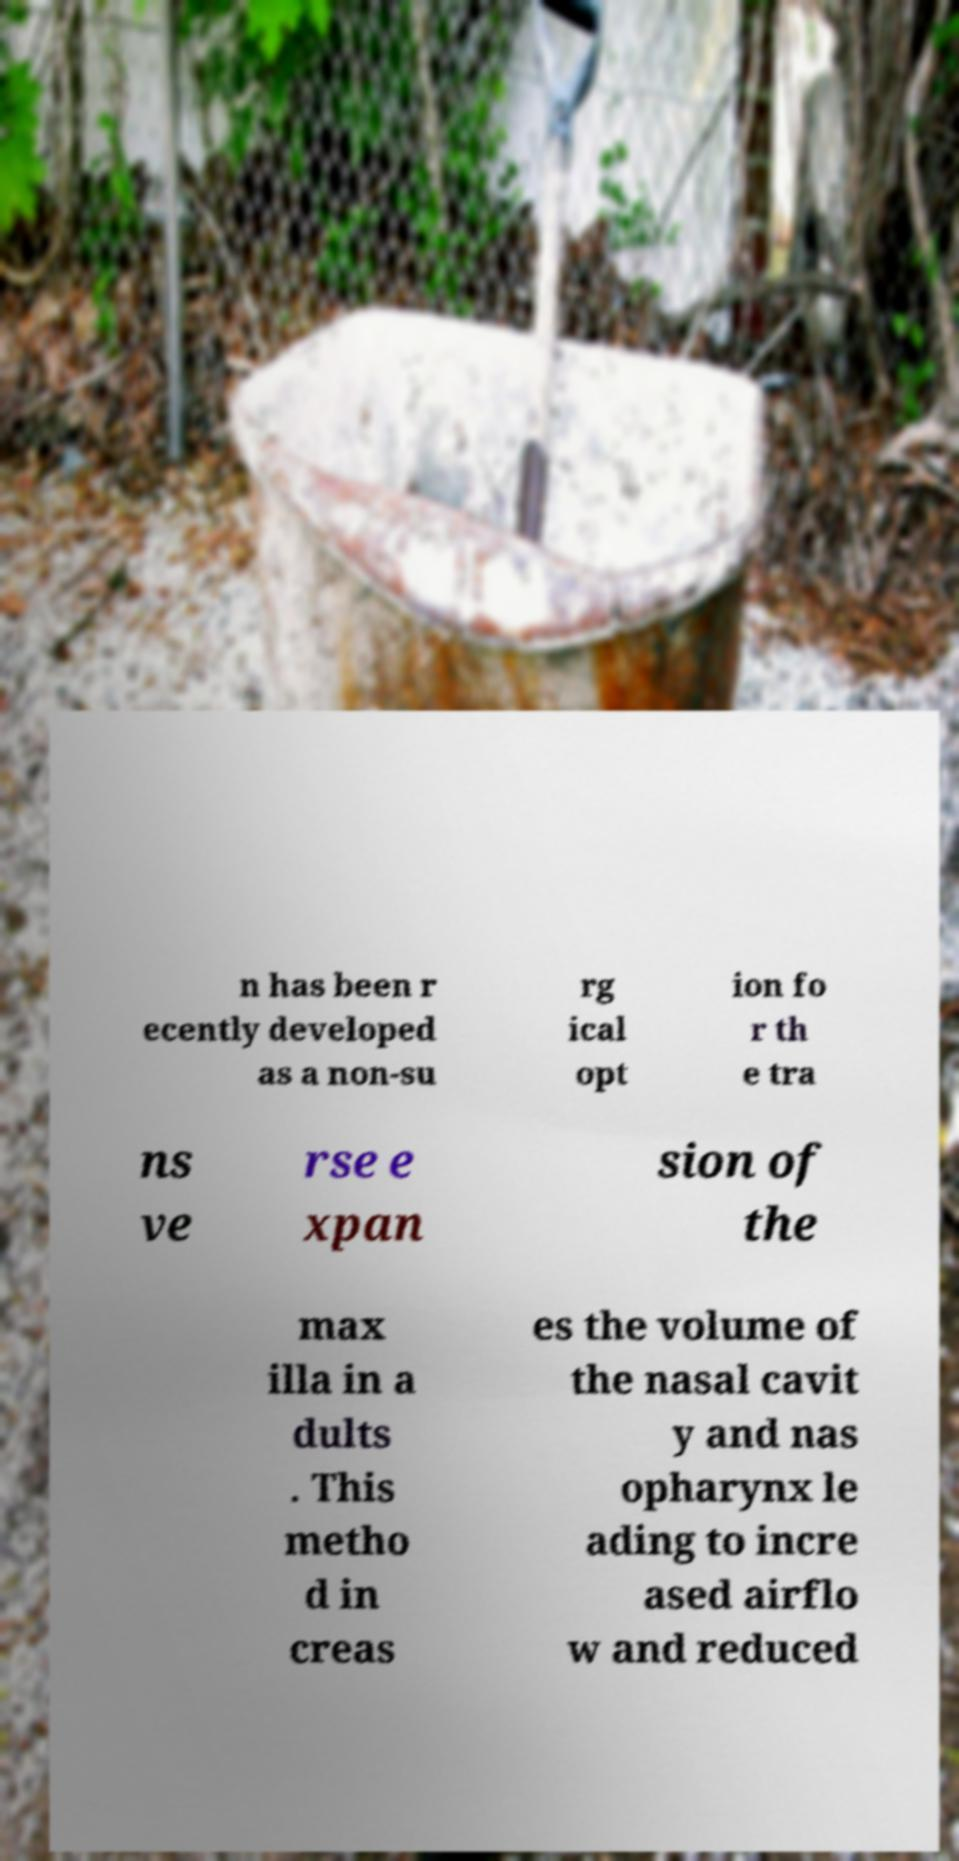There's text embedded in this image that I need extracted. Can you transcribe it verbatim? n has been r ecently developed as a non-su rg ical opt ion fo r th e tra ns ve rse e xpan sion of the max illa in a dults . This metho d in creas es the volume of the nasal cavit y and nas opharynx le ading to incre ased airflo w and reduced 